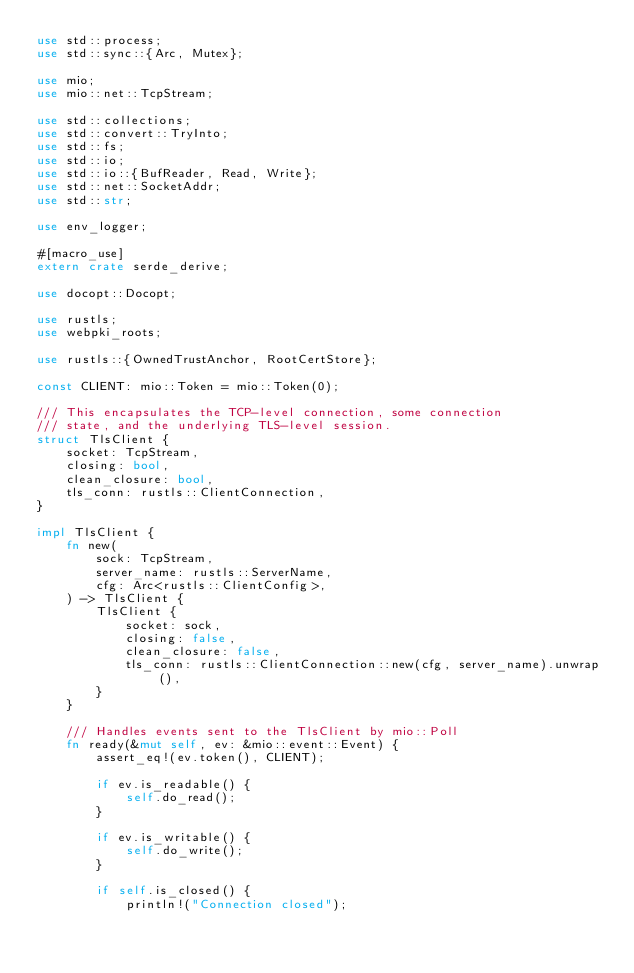<code> <loc_0><loc_0><loc_500><loc_500><_Rust_>use std::process;
use std::sync::{Arc, Mutex};

use mio;
use mio::net::TcpStream;

use std::collections;
use std::convert::TryInto;
use std::fs;
use std::io;
use std::io::{BufReader, Read, Write};
use std::net::SocketAddr;
use std::str;

use env_logger;

#[macro_use]
extern crate serde_derive;

use docopt::Docopt;

use rustls;
use webpki_roots;

use rustls::{OwnedTrustAnchor, RootCertStore};

const CLIENT: mio::Token = mio::Token(0);

/// This encapsulates the TCP-level connection, some connection
/// state, and the underlying TLS-level session.
struct TlsClient {
    socket: TcpStream,
    closing: bool,
    clean_closure: bool,
    tls_conn: rustls::ClientConnection,
}

impl TlsClient {
    fn new(
        sock: TcpStream,
        server_name: rustls::ServerName,
        cfg: Arc<rustls::ClientConfig>,
    ) -> TlsClient {
        TlsClient {
            socket: sock,
            closing: false,
            clean_closure: false,
            tls_conn: rustls::ClientConnection::new(cfg, server_name).unwrap(),
        }
    }

    /// Handles events sent to the TlsClient by mio::Poll
    fn ready(&mut self, ev: &mio::event::Event) {
        assert_eq!(ev.token(), CLIENT);

        if ev.is_readable() {
            self.do_read();
        }

        if ev.is_writable() {
            self.do_write();
        }

        if self.is_closed() {
            println!("Connection closed");</code> 